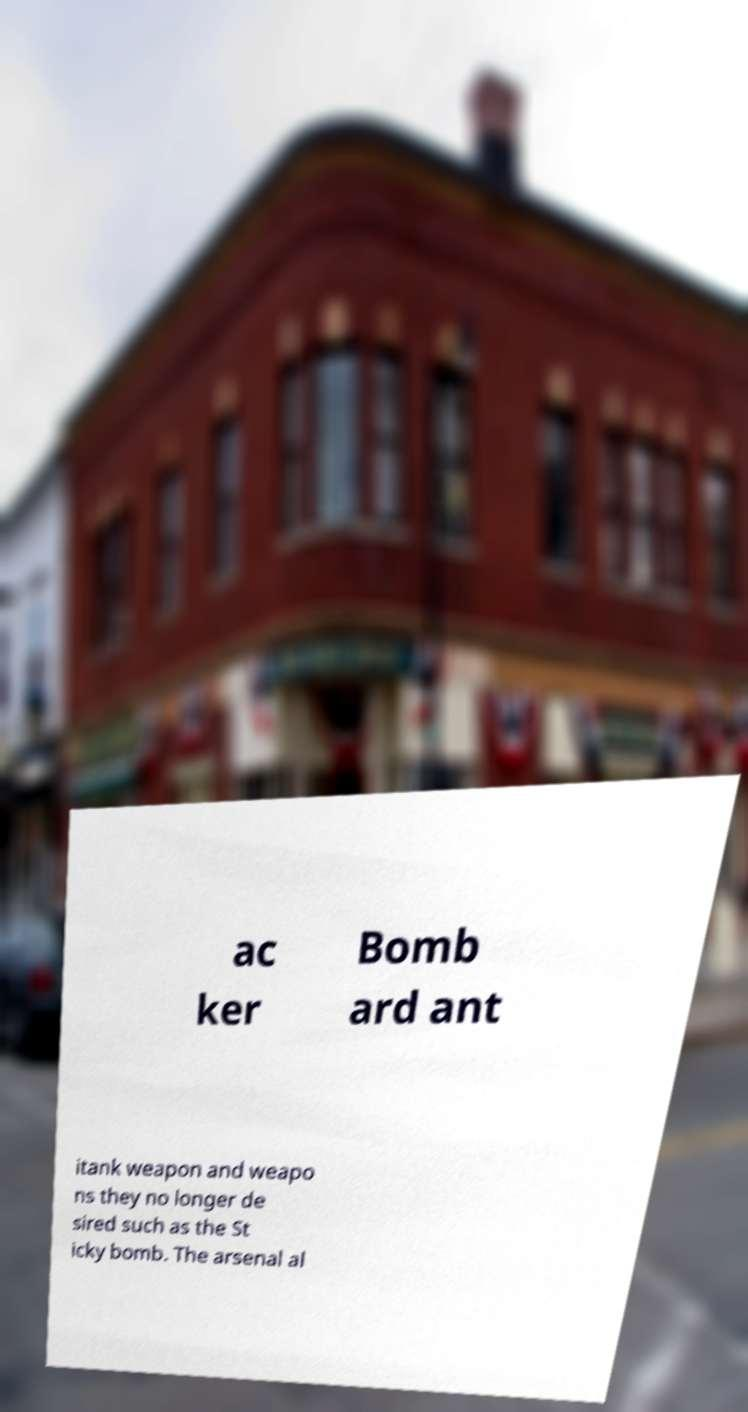There's text embedded in this image that I need extracted. Can you transcribe it verbatim? ac ker Bomb ard ant itank weapon and weapo ns they no longer de sired such as the St icky bomb. The arsenal al 